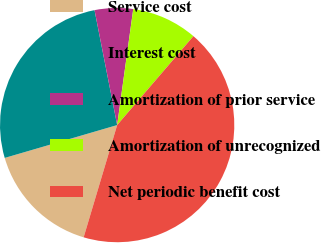<chart> <loc_0><loc_0><loc_500><loc_500><pie_chart><fcel>Service cost<fcel>Interest cost<fcel>Amortization of prior service<fcel>Amortization of unrecognized<fcel>Net periodic benefit cost<nl><fcel>15.86%<fcel>26.43%<fcel>5.29%<fcel>9.09%<fcel>43.34%<nl></chart> 